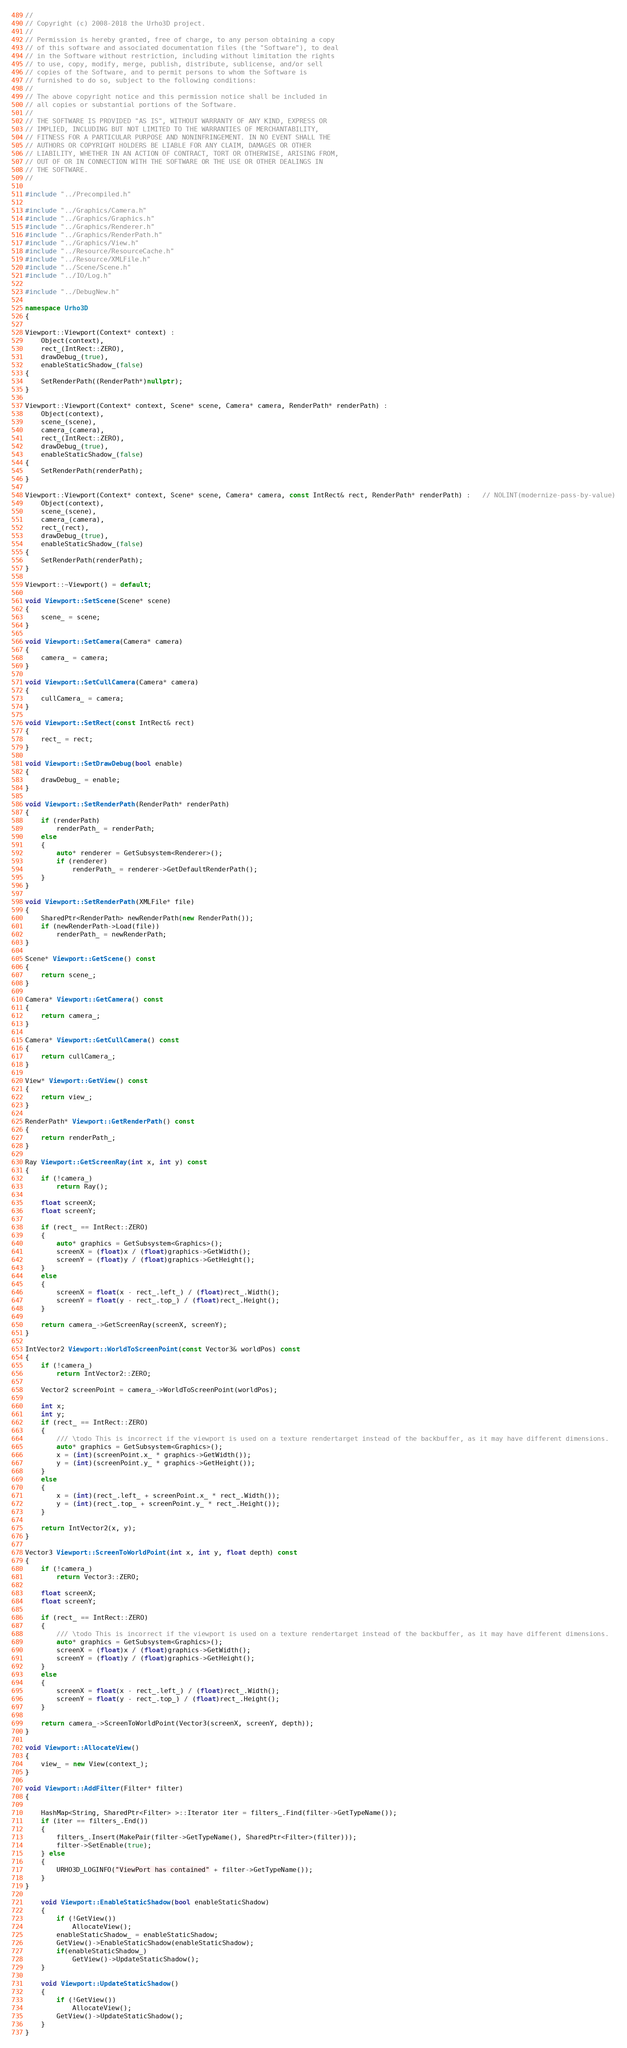Convert code to text. <code><loc_0><loc_0><loc_500><loc_500><_C++_>//
// Copyright (c) 2008-2018 the Urho3D project.
//
// Permission is hereby granted, free of charge, to any person obtaining a copy
// of this software and associated documentation files (the "Software"), to deal
// in the Software without restriction, including without limitation the rights
// to use, copy, modify, merge, publish, distribute, sublicense, and/or sell
// copies of the Software, and to permit persons to whom the Software is
// furnished to do so, subject to the following conditions:
//
// The above copyright notice and this permission notice shall be included in
// all copies or substantial portions of the Software.
//
// THE SOFTWARE IS PROVIDED "AS IS", WITHOUT WARRANTY OF ANY KIND, EXPRESS OR
// IMPLIED, INCLUDING BUT NOT LIMITED TO THE WARRANTIES OF MERCHANTABILITY,
// FITNESS FOR A PARTICULAR PURPOSE AND NONINFRINGEMENT. IN NO EVENT SHALL THE
// AUTHORS OR COPYRIGHT HOLDERS BE LIABLE FOR ANY CLAIM, DAMAGES OR OTHER
// LIABILITY, WHETHER IN AN ACTION OF CONTRACT, TORT OR OTHERWISE, ARISING FROM,
// OUT OF OR IN CONNECTION WITH THE SOFTWARE OR THE USE OR OTHER DEALINGS IN
// THE SOFTWARE.
//

#include "../Precompiled.h"

#include "../Graphics/Camera.h"
#include "../Graphics/Graphics.h"
#include "../Graphics/Renderer.h"
#include "../Graphics/RenderPath.h"
#include "../Graphics/View.h"
#include "../Resource/ResourceCache.h"
#include "../Resource/XMLFile.h"
#include "../Scene/Scene.h"
#include "../IO/Log.h"

#include "../DebugNew.h"

namespace Urho3D
{

Viewport::Viewport(Context* context) :
    Object(context),
    rect_(IntRect::ZERO),
    drawDebug_(true),
	enableStaticShadow_(false)
{
    SetRenderPath((RenderPath*)nullptr);
}

Viewport::Viewport(Context* context, Scene* scene, Camera* camera, RenderPath* renderPath) :
    Object(context),
    scene_(scene),
    camera_(camera),
    rect_(IntRect::ZERO),
    drawDebug_(true),
	enableStaticShadow_(false)
{
    SetRenderPath(renderPath);
}

Viewport::Viewport(Context* context, Scene* scene, Camera* camera, const IntRect& rect, RenderPath* renderPath) :   // NOLINT(modernize-pass-by-value)
    Object(context),
    scene_(scene),
    camera_(camera),
    rect_(rect),
    drawDebug_(true),
	enableStaticShadow_(false)
{
    SetRenderPath(renderPath);
}

Viewport::~Viewport() = default;

void Viewport::SetScene(Scene* scene)
{
    scene_ = scene;
}

void Viewport::SetCamera(Camera* camera)
{
    camera_ = camera;
}

void Viewport::SetCullCamera(Camera* camera)
{
    cullCamera_ = camera;
}

void Viewport::SetRect(const IntRect& rect)
{
    rect_ = rect;
}

void Viewport::SetDrawDebug(bool enable)
{
    drawDebug_ = enable;
}

void Viewport::SetRenderPath(RenderPath* renderPath)
{
    if (renderPath)
        renderPath_ = renderPath;
    else
    {
        auto* renderer = GetSubsystem<Renderer>();
        if (renderer)
            renderPath_ = renderer->GetDefaultRenderPath();
    }
}

void Viewport::SetRenderPath(XMLFile* file)
{
    SharedPtr<RenderPath> newRenderPath(new RenderPath());
    if (newRenderPath->Load(file))
        renderPath_ = newRenderPath;
}

Scene* Viewport::GetScene() const
{
    return scene_;
}

Camera* Viewport::GetCamera() const
{
    return camera_;
}

Camera* Viewport::GetCullCamera() const
{
    return cullCamera_;
}

View* Viewport::GetView() const
{
    return view_;
}

RenderPath* Viewport::GetRenderPath() const
{
    return renderPath_;
}

Ray Viewport::GetScreenRay(int x, int y) const
{
    if (!camera_)
        return Ray();

    float screenX;
    float screenY;

    if (rect_ == IntRect::ZERO)
    {
        auto* graphics = GetSubsystem<Graphics>();
        screenX = (float)x / (float)graphics->GetWidth();
        screenY = (float)y / (float)graphics->GetHeight();
    }
    else
    {
        screenX = float(x - rect_.left_) / (float)rect_.Width();
        screenY = float(y - rect_.top_) / (float)rect_.Height();
    }

    return camera_->GetScreenRay(screenX, screenY);
}

IntVector2 Viewport::WorldToScreenPoint(const Vector3& worldPos) const
{
    if (!camera_)
        return IntVector2::ZERO;

    Vector2 screenPoint = camera_->WorldToScreenPoint(worldPos);

    int x;
    int y;
    if (rect_ == IntRect::ZERO)
    {
        /// \todo This is incorrect if the viewport is used on a texture rendertarget instead of the backbuffer, as it may have different dimensions.
        auto* graphics = GetSubsystem<Graphics>();
        x = (int)(screenPoint.x_ * graphics->GetWidth());
        y = (int)(screenPoint.y_ * graphics->GetHeight());
    }
    else
    {
        x = (int)(rect_.left_ + screenPoint.x_ * rect_.Width());
        y = (int)(rect_.top_ + screenPoint.y_ * rect_.Height());
    }

    return IntVector2(x, y);
}

Vector3 Viewport::ScreenToWorldPoint(int x, int y, float depth) const
{
    if (!camera_)
        return Vector3::ZERO;

    float screenX;
    float screenY;

    if (rect_ == IntRect::ZERO)
    {
        /// \todo This is incorrect if the viewport is used on a texture rendertarget instead of the backbuffer, as it may have different dimensions.
        auto* graphics = GetSubsystem<Graphics>();
        screenX = (float)x / (float)graphics->GetWidth();
        screenY = (float)y / (float)graphics->GetHeight();
    }
    else
    {
        screenX = float(x - rect_.left_) / (float)rect_.Width();
        screenY = float(y - rect_.top_) / (float)rect_.Height();
    }

    return camera_->ScreenToWorldPoint(Vector3(screenX, screenY, depth));
}

void Viewport::AllocateView()
{
    view_ = new View(context_);
}

void Viewport::AddFilter(Filter* filter)
{
	
	HashMap<String, SharedPtr<Filter> >::Iterator iter = filters_.Find(filter->GetTypeName());
	if (iter == filters_.End())
	{
		filters_.Insert(MakePair(filter->GetTypeName(), SharedPtr<Filter>(filter)));
		filter->SetEnable(true);
	} else
	{
		URHO3D_LOGINFO("ViewPort has contained" + filter->GetTypeName());
	}
}

	void Viewport::EnableStaticShadow(bool enableStaticShadow)
	{
		if (!GetView())
			AllocateView();
		enableStaticShadow_ = enableStaticShadow;
		GetView()->EnableStaticShadow(enableStaticShadow);
		if(enableStaticShadow_)
			GetView()->UpdateStaticShadow();
	}

	void Viewport::UpdateStaticShadow()
	{
		if (!GetView())
			AllocateView();
		GetView()->UpdateStaticShadow();
	}
}
</code> 